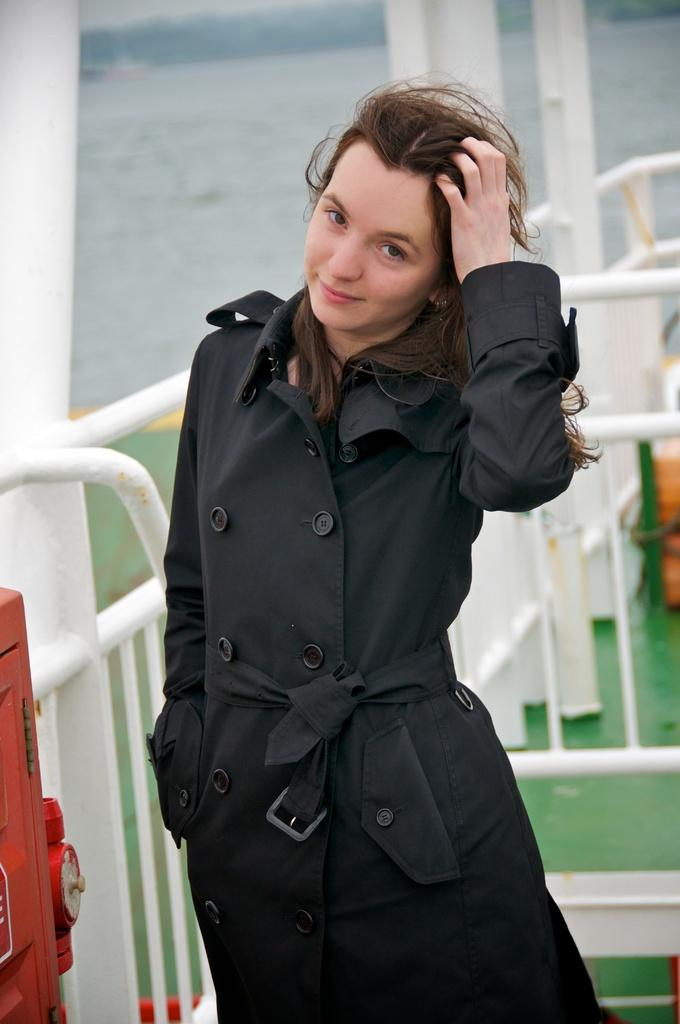Who is present in the image? There is a woman in the image. What is the woman wearing? The woman is wearing a black coat. What type of architectural feature can be seen in the image? There are iron grilles visible in the image. What is the liquid element present in the image? There is water in the image. Can you describe the object on the left side of the image? Unfortunately, the facts provided do not give enough information to describe the object on the left side of the image. Is the woman holding a rifle in the image? No, there is no rifle present in the image. Is the scene taking place during winter in the image? The facts provided do not give any information about the season or weather, so we cannot determine if it is winter. 